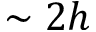Convert formula to latex. <formula><loc_0><loc_0><loc_500><loc_500>\sim 2 h</formula> 